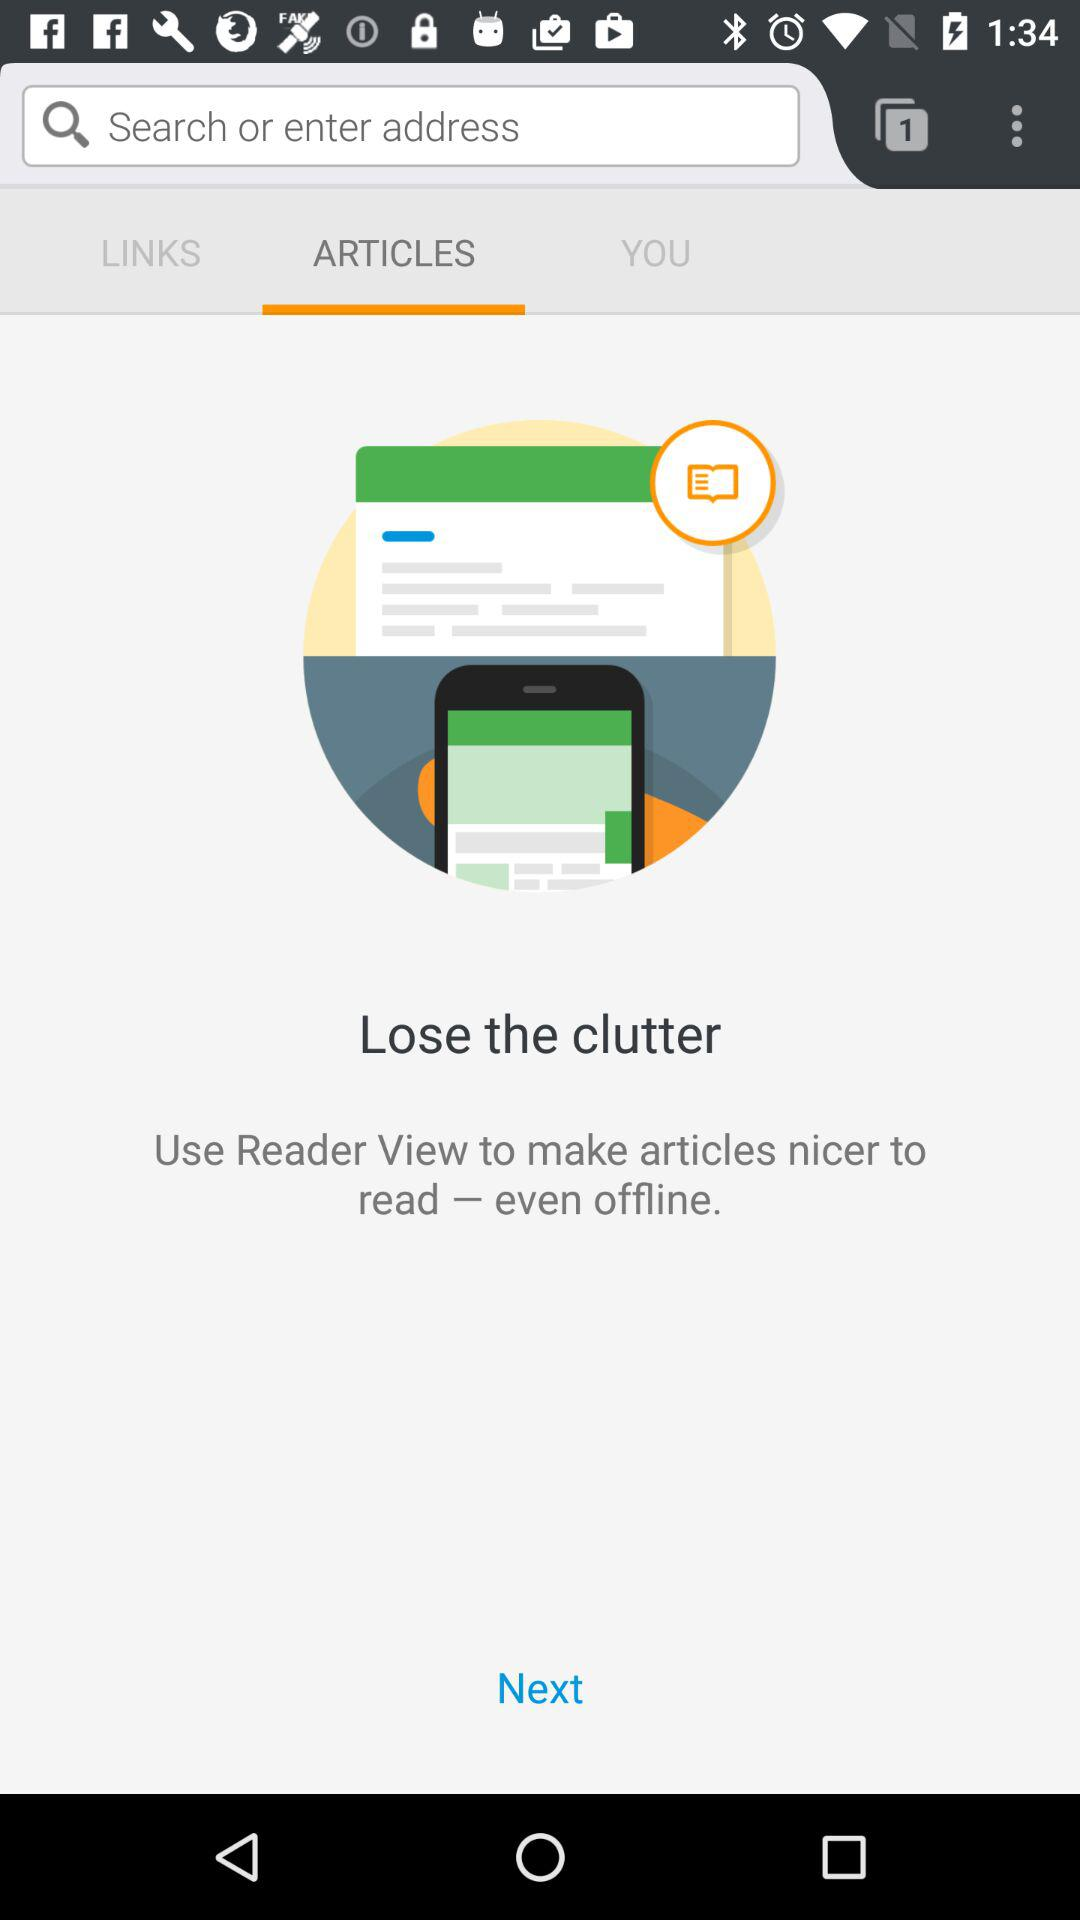Which tab is selected? The selected tab is "ARTICLES". 